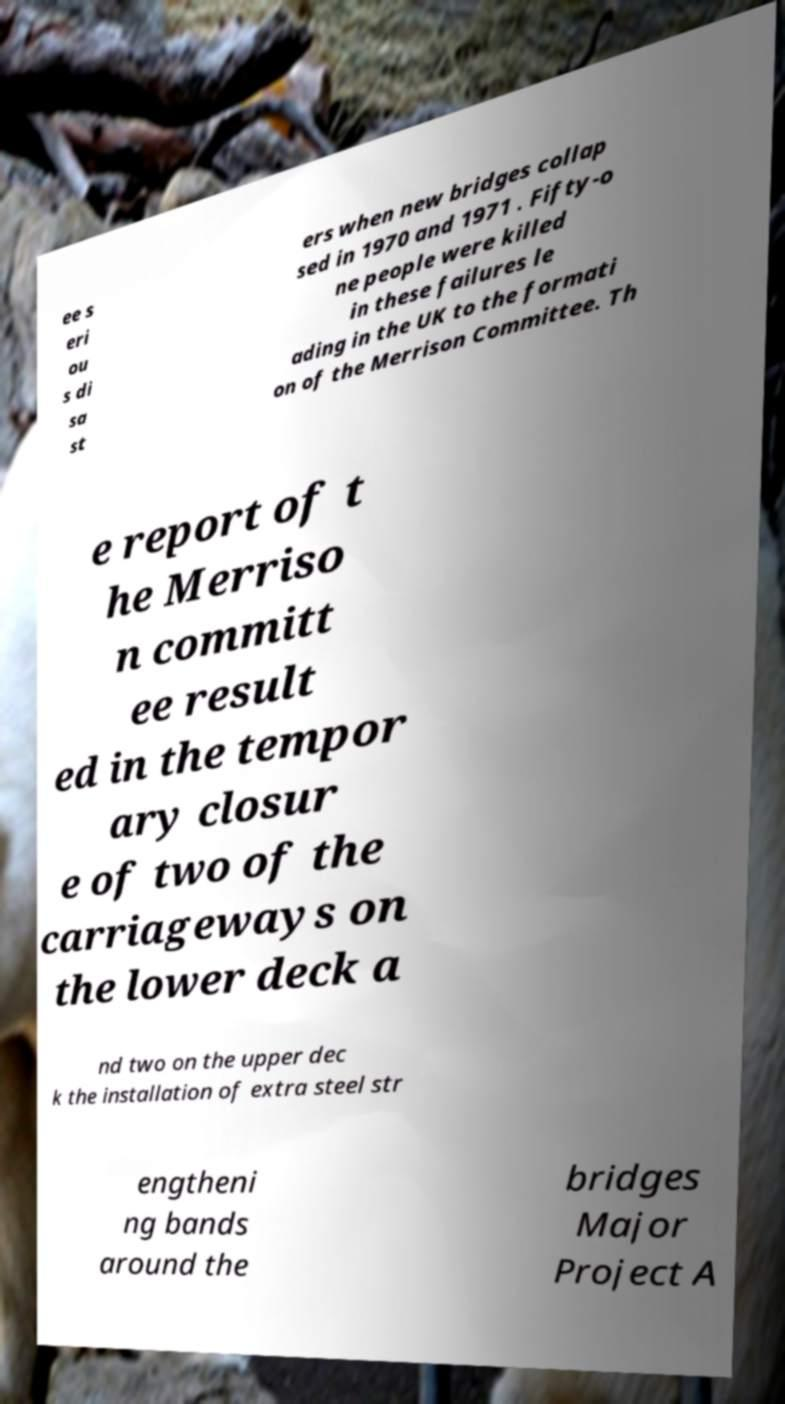Could you assist in decoding the text presented in this image and type it out clearly? ee s eri ou s di sa st ers when new bridges collap sed in 1970 and 1971 . Fifty-o ne people were killed in these failures le ading in the UK to the formati on of the Merrison Committee. Th e report of t he Merriso n committ ee result ed in the tempor ary closur e of two of the carriageways on the lower deck a nd two on the upper dec k the installation of extra steel str engtheni ng bands around the bridges Major Project A 